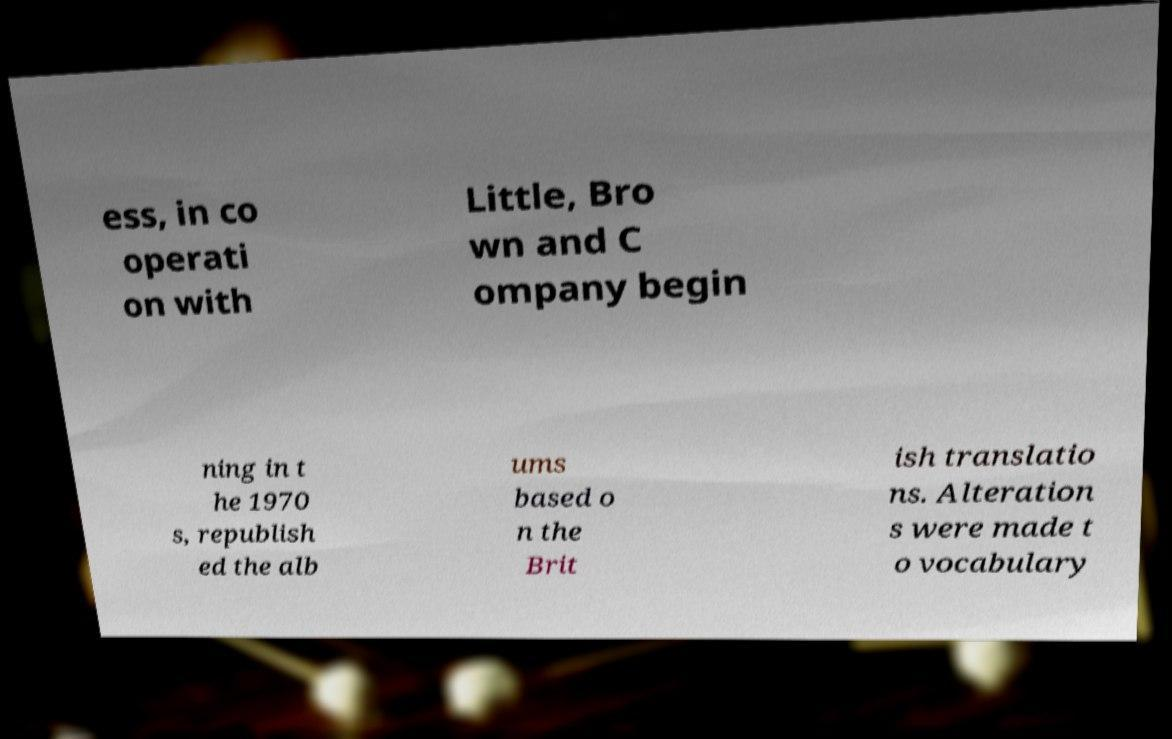Please read and relay the text visible in this image. What does it say? ess, in co operati on with Little, Bro wn and C ompany begin ning in t he 1970 s, republish ed the alb ums based o n the Brit ish translatio ns. Alteration s were made t o vocabulary 